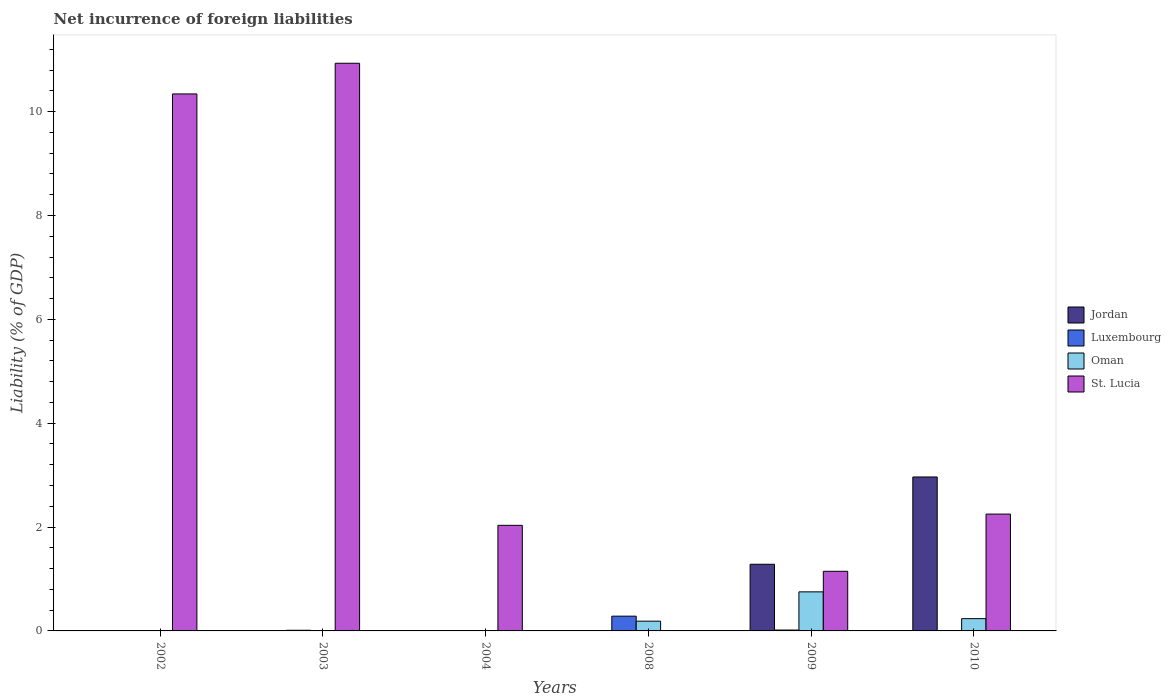How many different coloured bars are there?
Keep it short and to the point. 4. Are the number of bars on each tick of the X-axis equal?
Give a very brief answer. No. How many bars are there on the 6th tick from the left?
Offer a very short reply. 4. How many bars are there on the 6th tick from the right?
Provide a short and direct response. 2. In how many cases, is the number of bars for a given year not equal to the number of legend labels?
Offer a very short reply. 4. What is the net incurrence of foreign liabilities in Oman in 2009?
Make the answer very short. 0.75. Across all years, what is the maximum net incurrence of foreign liabilities in Luxembourg?
Ensure brevity in your answer.  0.28. What is the total net incurrence of foreign liabilities in Jordan in the graph?
Keep it short and to the point. 4.25. What is the difference between the net incurrence of foreign liabilities in Luxembourg in 2002 and that in 2009?
Provide a succinct answer. -0.01. What is the difference between the net incurrence of foreign liabilities in Luxembourg in 2010 and the net incurrence of foreign liabilities in St. Lucia in 2004?
Offer a very short reply. -2.03. What is the average net incurrence of foreign liabilities in Jordan per year?
Provide a short and direct response. 0.71. In the year 2010, what is the difference between the net incurrence of foreign liabilities in Jordan and net incurrence of foreign liabilities in Luxembourg?
Make the answer very short. 2.96. In how many years, is the net incurrence of foreign liabilities in St. Lucia greater than 4.8 %?
Keep it short and to the point. 2. What is the ratio of the net incurrence of foreign liabilities in Luxembourg in 2003 to that in 2010?
Offer a terse response. 1.69. What is the difference between the highest and the second highest net incurrence of foreign liabilities in Luxembourg?
Provide a succinct answer. 0.27. What is the difference between the highest and the lowest net incurrence of foreign liabilities in Luxembourg?
Offer a terse response. 0.28. In how many years, is the net incurrence of foreign liabilities in Oman greater than the average net incurrence of foreign liabilities in Oman taken over all years?
Your answer should be very brief. 2. Is it the case that in every year, the sum of the net incurrence of foreign liabilities in Jordan and net incurrence of foreign liabilities in Oman is greater than the sum of net incurrence of foreign liabilities in St. Lucia and net incurrence of foreign liabilities in Luxembourg?
Keep it short and to the point. No. What is the difference between two consecutive major ticks on the Y-axis?
Give a very brief answer. 2. Does the graph contain any zero values?
Make the answer very short. Yes. Where does the legend appear in the graph?
Provide a short and direct response. Center right. What is the title of the graph?
Provide a short and direct response. Net incurrence of foreign liabilities. What is the label or title of the Y-axis?
Your answer should be very brief. Liability (% of GDP). What is the Liability (% of GDP) in Luxembourg in 2002?
Provide a short and direct response. 0.01. What is the Liability (% of GDP) of Oman in 2002?
Your answer should be very brief. 0. What is the Liability (% of GDP) in St. Lucia in 2002?
Provide a short and direct response. 10.34. What is the Liability (% of GDP) in Jordan in 2003?
Your answer should be compact. 0. What is the Liability (% of GDP) in Luxembourg in 2003?
Provide a short and direct response. 0.01. What is the Liability (% of GDP) in St. Lucia in 2003?
Provide a short and direct response. 10.93. What is the Liability (% of GDP) of St. Lucia in 2004?
Your answer should be compact. 2.03. What is the Liability (% of GDP) in Luxembourg in 2008?
Offer a very short reply. 0.28. What is the Liability (% of GDP) of Oman in 2008?
Your answer should be very brief. 0.19. What is the Liability (% of GDP) in Jordan in 2009?
Give a very brief answer. 1.28. What is the Liability (% of GDP) of Luxembourg in 2009?
Make the answer very short. 0.02. What is the Liability (% of GDP) in Oman in 2009?
Your answer should be very brief. 0.75. What is the Liability (% of GDP) in St. Lucia in 2009?
Provide a succinct answer. 1.15. What is the Liability (% of GDP) of Jordan in 2010?
Offer a very short reply. 2.96. What is the Liability (% of GDP) in Luxembourg in 2010?
Keep it short and to the point. 0.01. What is the Liability (% of GDP) of Oman in 2010?
Your response must be concise. 0.24. What is the Liability (% of GDP) of St. Lucia in 2010?
Offer a very short reply. 2.25. Across all years, what is the maximum Liability (% of GDP) of Jordan?
Keep it short and to the point. 2.96. Across all years, what is the maximum Liability (% of GDP) in Luxembourg?
Make the answer very short. 0.28. Across all years, what is the maximum Liability (% of GDP) of Oman?
Provide a succinct answer. 0.75. Across all years, what is the maximum Liability (% of GDP) of St. Lucia?
Give a very brief answer. 10.93. Across all years, what is the minimum Liability (% of GDP) of Jordan?
Give a very brief answer. 0. Across all years, what is the minimum Liability (% of GDP) of Luxembourg?
Offer a very short reply. 0. What is the total Liability (% of GDP) in Jordan in the graph?
Offer a very short reply. 4.25. What is the total Liability (% of GDP) of Luxembourg in the graph?
Your response must be concise. 0.33. What is the total Liability (% of GDP) of Oman in the graph?
Offer a very short reply. 1.18. What is the total Liability (% of GDP) of St. Lucia in the graph?
Offer a very short reply. 26.7. What is the difference between the Liability (% of GDP) in Luxembourg in 2002 and that in 2003?
Give a very brief answer. -0.01. What is the difference between the Liability (% of GDP) in St. Lucia in 2002 and that in 2003?
Ensure brevity in your answer.  -0.59. What is the difference between the Liability (% of GDP) of St. Lucia in 2002 and that in 2004?
Ensure brevity in your answer.  8.31. What is the difference between the Liability (% of GDP) of Luxembourg in 2002 and that in 2008?
Make the answer very short. -0.28. What is the difference between the Liability (% of GDP) of Luxembourg in 2002 and that in 2009?
Make the answer very short. -0.01. What is the difference between the Liability (% of GDP) of St. Lucia in 2002 and that in 2009?
Your response must be concise. 9.19. What is the difference between the Liability (% of GDP) in Luxembourg in 2002 and that in 2010?
Provide a short and direct response. -0. What is the difference between the Liability (% of GDP) of St. Lucia in 2002 and that in 2010?
Ensure brevity in your answer.  8.09. What is the difference between the Liability (% of GDP) in St. Lucia in 2003 and that in 2004?
Your answer should be very brief. 8.9. What is the difference between the Liability (% of GDP) in Luxembourg in 2003 and that in 2008?
Offer a very short reply. -0.27. What is the difference between the Liability (% of GDP) in Luxembourg in 2003 and that in 2009?
Your answer should be very brief. -0. What is the difference between the Liability (% of GDP) in St. Lucia in 2003 and that in 2009?
Your answer should be very brief. 9.78. What is the difference between the Liability (% of GDP) of Luxembourg in 2003 and that in 2010?
Provide a succinct answer. 0.01. What is the difference between the Liability (% of GDP) of St. Lucia in 2003 and that in 2010?
Make the answer very short. 8.68. What is the difference between the Liability (% of GDP) of St. Lucia in 2004 and that in 2009?
Give a very brief answer. 0.88. What is the difference between the Liability (% of GDP) of St. Lucia in 2004 and that in 2010?
Provide a succinct answer. -0.22. What is the difference between the Liability (% of GDP) in Luxembourg in 2008 and that in 2009?
Your response must be concise. 0.27. What is the difference between the Liability (% of GDP) in Oman in 2008 and that in 2009?
Offer a terse response. -0.56. What is the difference between the Liability (% of GDP) of Luxembourg in 2008 and that in 2010?
Offer a very short reply. 0.28. What is the difference between the Liability (% of GDP) in Oman in 2008 and that in 2010?
Keep it short and to the point. -0.05. What is the difference between the Liability (% of GDP) of Jordan in 2009 and that in 2010?
Keep it short and to the point. -1.68. What is the difference between the Liability (% of GDP) of Luxembourg in 2009 and that in 2010?
Offer a terse response. 0.01. What is the difference between the Liability (% of GDP) in Oman in 2009 and that in 2010?
Your answer should be very brief. 0.52. What is the difference between the Liability (% of GDP) in St. Lucia in 2009 and that in 2010?
Your answer should be very brief. -1.1. What is the difference between the Liability (% of GDP) of Luxembourg in 2002 and the Liability (% of GDP) of St. Lucia in 2003?
Give a very brief answer. -10.92. What is the difference between the Liability (% of GDP) of Luxembourg in 2002 and the Liability (% of GDP) of St. Lucia in 2004?
Make the answer very short. -2.03. What is the difference between the Liability (% of GDP) in Luxembourg in 2002 and the Liability (% of GDP) in Oman in 2008?
Ensure brevity in your answer.  -0.18. What is the difference between the Liability (% of GDP) in Luxembourg in 2002 and the Liability (% of GDP) in Oman in 2009?
Make the answer very short. -0.75. What is the difference between the Liability (% of GDP) of Luxembourg in 2002 and the Liability (% of GDP) of St. Lucia in 2009?
Your answer should be compact. -1.14. What is the difference between the Liability (% of GDP) in Luxembourg in 2002 and the Liability (% of GDP) in Oman in 2010?
Your response must be concise. -0.23. What is the difference between the Liability (% of GDP) of Luxembourg in 2002 and the Liability (% of GDP) of St. Lucia in 2010?
Ensure brevity in your answer.  -2.24. What is the difference between the Liability (% of GDP) of Luxembourg in 2003 and the Liability (% of GDP) of St. Lucia in 2004?
Give a very brief answer. -2.02. What is the difference between the Liability (% of GDP) of Luxembourg in 2003 and the Liability (% of GDP) of Oman in 2008?
Offer a terse response. -0.18. What is the difference between the Liability (% of GDP) of Luxembourg in 2003 and the Liability (% of GDP) of Oman in 2009?
Offer a terse response. -0.74. What is the difference between the Liability (% of GDP) in Luxembourg in 2003 and the Liability (% of GDP) in St. Lucia in 2009?
Ensure brevity in your answer.  -1.14. What is the difference between the Liability (% of GDP) of Luxembourg in 2003 and the Liability (% of GDP) of Oman in 2010?
Ensure brevity in your answer.  -0.22. What is the difference between the Liability (% of GDP) in Luxembourg in 2003 and the Liability (% of GDP) in St. Lucia in 2010?
Provide a short and direct response. -2.24. What is the difference between the Liability (% of GDP) of Luxembourg in 2008 and the Liability (% of GDP) of Oman in 2009?
Offer a terse response. -0.47. What is the difference between the Liability (% of GDP) of Luxembourg in 2008 and the Liability (% of GDP) of St. Lucia in 2009?
Provide a short and direct response. -0.86. What is the difference between the Liability (% of GDP) in Oman in 2008 and the Liability (% of GDP) in St. Lucia in 2009?
Provide a short and direct response. -0.96. What is the difference between the Liability (% of GDP) in Luxembourg in 2008 and the Liability (% of GDP) in Oman in 2010?
Ensure brevity in your answer.  0.05. What is the difference between the Liability (% of GDP) in Luxembourg in 2008 and the Liability (% of GDP) in St. Lucia in 2010?
Provide a succinct answer. -1.97. What is the difference between the Liability (% of GDP) of Oman in 2008 and the Liability (% of GDP) of St. Lucia in 2010?
Your response must be concise. -2.06. What is the difference between the Liability (% of GDP) of Jordan in 2009 and the Liability (% of GDP) of Luxembourg in 2010?
Your answer should be compact. 1.28. What is the difference between the Liability (% of GDP) in Jordan in 2009 and the Liability (% of GDP) in Oman in 2010?
Make the answer very short. 1.05. What is the difference between the Liability (% of GDP) in Jordan in 2009 and the Liability (% of GDP) in St. Lucia in 2010?
Your response must be concise. -0.97. What is the difference between the Liability (% of GDP) of Luxembourg in 2009 and the Liability (% of GDP) of Oman in 2010?
Offer a terse response. -0.22. What is the difference between the Liability (% of GDP) of Luxembourg in 2009 and the Liability (% of GDP) of St. Lucia in 2010?
Keep it short and to the point. -2.23. What is the difference between the Liability (% of GDP) of Oman in 2009 and the Liability (% of GDP) of St. Lucia in 2010?
Your answer should be very brief. -1.5. What is the average Liability (% of GDP) in Jordan per year?
Provide a succinct answer. 0.71. What is the average Liability (% of GDP) in Luxembourg per year?
Give a very brief answer. 0.05. What is the average Liability (% of GDP) in Oman per year?
Your response must be concise. 0.2. What is the average Liability (% of GDP) in St. Lucia per year?
Your answer should be very brief. 4.45. In the year 2002, what is the difference between the Liability (% of GDP) of Luxembourg and Liability (% of GDP) of St. Lucia?
Provide a succinct answer. -10.33. In the year 2003, what is the difference between the Liability (% of GDP) of Luxembourg and Liability (% of GDP) of St. Lucia?
Ensure brevity in your answer.  -10.92. In the year 2008, what is the difference between the Liability (% of GDP) of Luxembourg and Liability (% of GDP) of Oman?
Provide a short and direct response. 0.1. In the year 2009, what is the difference between the Liability (% of GDP) in Jordan and Liability (% of GDP) in Luxembourg?
Ensure brevity in your answer.  1.27. In the year 2009, what is the difference between the Liability (% of GDP) of Jordan and Liability (% of GDP) of Oman?
Your response must be concise. 0.53. In the year 2009, what is the difference between the Liability (% of GDP) of Jordan and Liability (% of GDP) of St. Lucia?
Keep it short and to the point. 0.14. In the year 2009, what is the difference between the Liability (% of GDP) in Luxembourg and Liability (% of GDP) in Oman?
Ensure brevity in your answer.  -0.74. In the year 2009, what is the difference between the Liability (% of GDP) in Luxembourg and Liability (% of GDP) in St. Lucia?
Ensure brevity in your answer.  -1.13. In the year 2009, what is the difference between the Liability (% of GDP) of Oman and Liability (% of GDP) of St. Lucia?
Provide a succinct answer. -0.4. In the year 2010, what is the difference between the Liability (% of GDP) of Jordan and Liability (% of GDP) of Luxembourg?
Provide a succinct answer. 2.96. In the year 2010, what is the difference between the Liability (% of GDP) in Jordan and Liability (% of GDP) in Oman?
Offer a terse response. 2.73. In the year 2010, what is the difference between the Liability (% of GDP) in Jordan and Liability (% of GDP) in St. Lucia?
Offer a very short reply. 0.71. In the year 2010, what is the difference between the Liability (% of GDP) of Luxembourg and Liability (% of GDP) of Oman?
Offer a very short reply. -0.23. In the year 2010, what is the difference between the Liability (% of GDP) of Luxembourg and Liability (% of GDP) of St. Lucia?
Your answer should be compact. -2.24. In the year 2010, what is the difference between the Liability (% of GDP) in Oman and Liability (% of GDP) in St. Lucia?
Keep it short and to the point. -2.01. What is the ratio of the Liability (% of GDP) of Luxembourg in 2002 to that in 2003?
Offer a terse response. 0.57. What is the ratio of the Liability (% of GDP) of St. Lucia in 2002 to that in 2003?
Keep it short and to the point. 0.95. What is the ratio of the Liability (% of GDP) of St. Lucia in 2002 to that in 2004?
Keep it short and to the point. 5.09. What is the ratio of the Liability (% of GDP) of Luxembourg in 2002 to that in 2008?
Offer a terse response. 0.03. What is the ratio of the Liability (% of GDP) in Luxembourg in 2002 to that in 2009?
Your answer should be compact. 0.43. What is the ratio of the Liability (% of GDP) in St. Lucia in 2002 to that in 2009?
Give a very brief answer. 9. What is the ratio of the Liability (% of GDP) in Luxembourg in 2002 to that in 2010?
Keep it short and to the point. 0.96. What is the ratio of the Liability (% of GDP) of St. Lucia in 2002 to that in 2010?
Offer a very short reply. 4.6. What is the ratio of the Liability (% of GDP) of St. Lucia in 2003 to that in 2004?
Keep it short and to the point. 5.38. What is the ratio of the Liability (% of GDP) in Luxembourg in 2003 to that in 2008?
Keep it short and to the point. 0.04. What is the ratio of the Liability (% of GDP) of Luxembourg in 2003 to that in 2009?
Offer a very short reply. 0.75. What is the ratio of the Liability (% of GDP) in St. Lucia in 2003 to that in 2009?
Keep it short and to the point. 9.52. What is the ratio of the Liability (% of GDP) in Luxembourg in 2003 to that in 2010?
Keep it short and to the point. 1.69. What is the ratio of the Liability (% of GDP) of St. Lucia in 2003 to that in 2010?
Provide a short and direct response. 4.86. What is the ratio of the Liability (% of GDP) in St. Lucia in 2004 to that in 2009?
Give a very brief answer. 1.77. What is the ratio of the Liability (% of GDP) in St. Lucia in 2004 to that in 2010?
Ensure brevity in your answer.  0.9. What is the ratio of the Liability (% of GDP) of Luxembourg in 2008 to that in 2009?
Ensure brevity in your answer.  16.63. What is the ratio of the Liability (% of GDP) of Oman in 2008 to that in 2009?
Give a very brief answer. 0.25. What is the ratio of the Liability (% of GDP) in Luxembourg in 2008 to that in 2010?
Your response must be concise. 37.45. What is the ratio of the Liability (% of GDP) in Oman in 2008 to that in 2010?
Offer a very short reply. 0.79. What is the ratio of the Liability (% of GDP) of Jordan in 2009 to that in 2010?
Make the answer very short. 0.43. What is the ratio of the Liability (% of GDP) in Luxembourg in 2009 to that in 2010?
Provide a succinct answer. 2.25. What is the ratio of the Liability (% of GDP) in Oman in 2009 to that in 2010?
Give a very brief answer. 3.18. What is the ratio of the Liability (% of GDP) of St. Lucia in 2009 to that in 2010?
Offer a terse response. 0.51. What is the difference between the highest and the second highest Liability (% of GDP) of Luxembourg?
Make the answer very short. 0.27. What is the difference between the highest and the second highest Liability (% of GDP) in Oman?
Ensure brevity in your answer.  0.52. What is the difference between the highest and the second highest Liability (% of GDP) in St. Lucia?
Provide a short and direct response. 0.59. What is the difference between the highest and the lowest Liability (% of GDP) in Jordan?
Provide a succinct answer. 2.96. What is the difference between the highest and the lowest Liability (% of GDP) of Luxembourg?
Offer a terse response. 0.28. What is the difference between the highest and the lowest Liability (% of GDP) of Oman?
Your response must be concise. 0.75. What is the difference between the highest and the lowest Liability (% of GDP) of St. Lucia?
Your answer should be compact. 10.93. 